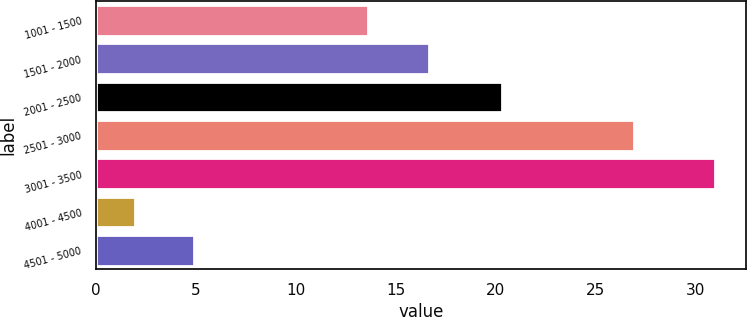Convert chart. <chart><loc_0><loc_0><loc_500><loc_500><bar_chart><fcel>1001 - 1500<fcel>1501 - 2000<fcel>2001 - 2500<fcel>2501 - 3000<fcel>3001 - 3500<fcel>4001 - 4500<fcel>4501 - 5000<nl><fcel>13.58<fcel>16.68<fcel>20.32<fcel>26.91<fcel>30.98<fcel>1.96<fcel>4.88<nl></chart> 